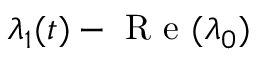<formula> <loc_0><loc_0><loc_500><loc_500>\lambda _ { 1 } ( t ) - R e ( \lambda _ { 0 } )</formula> 